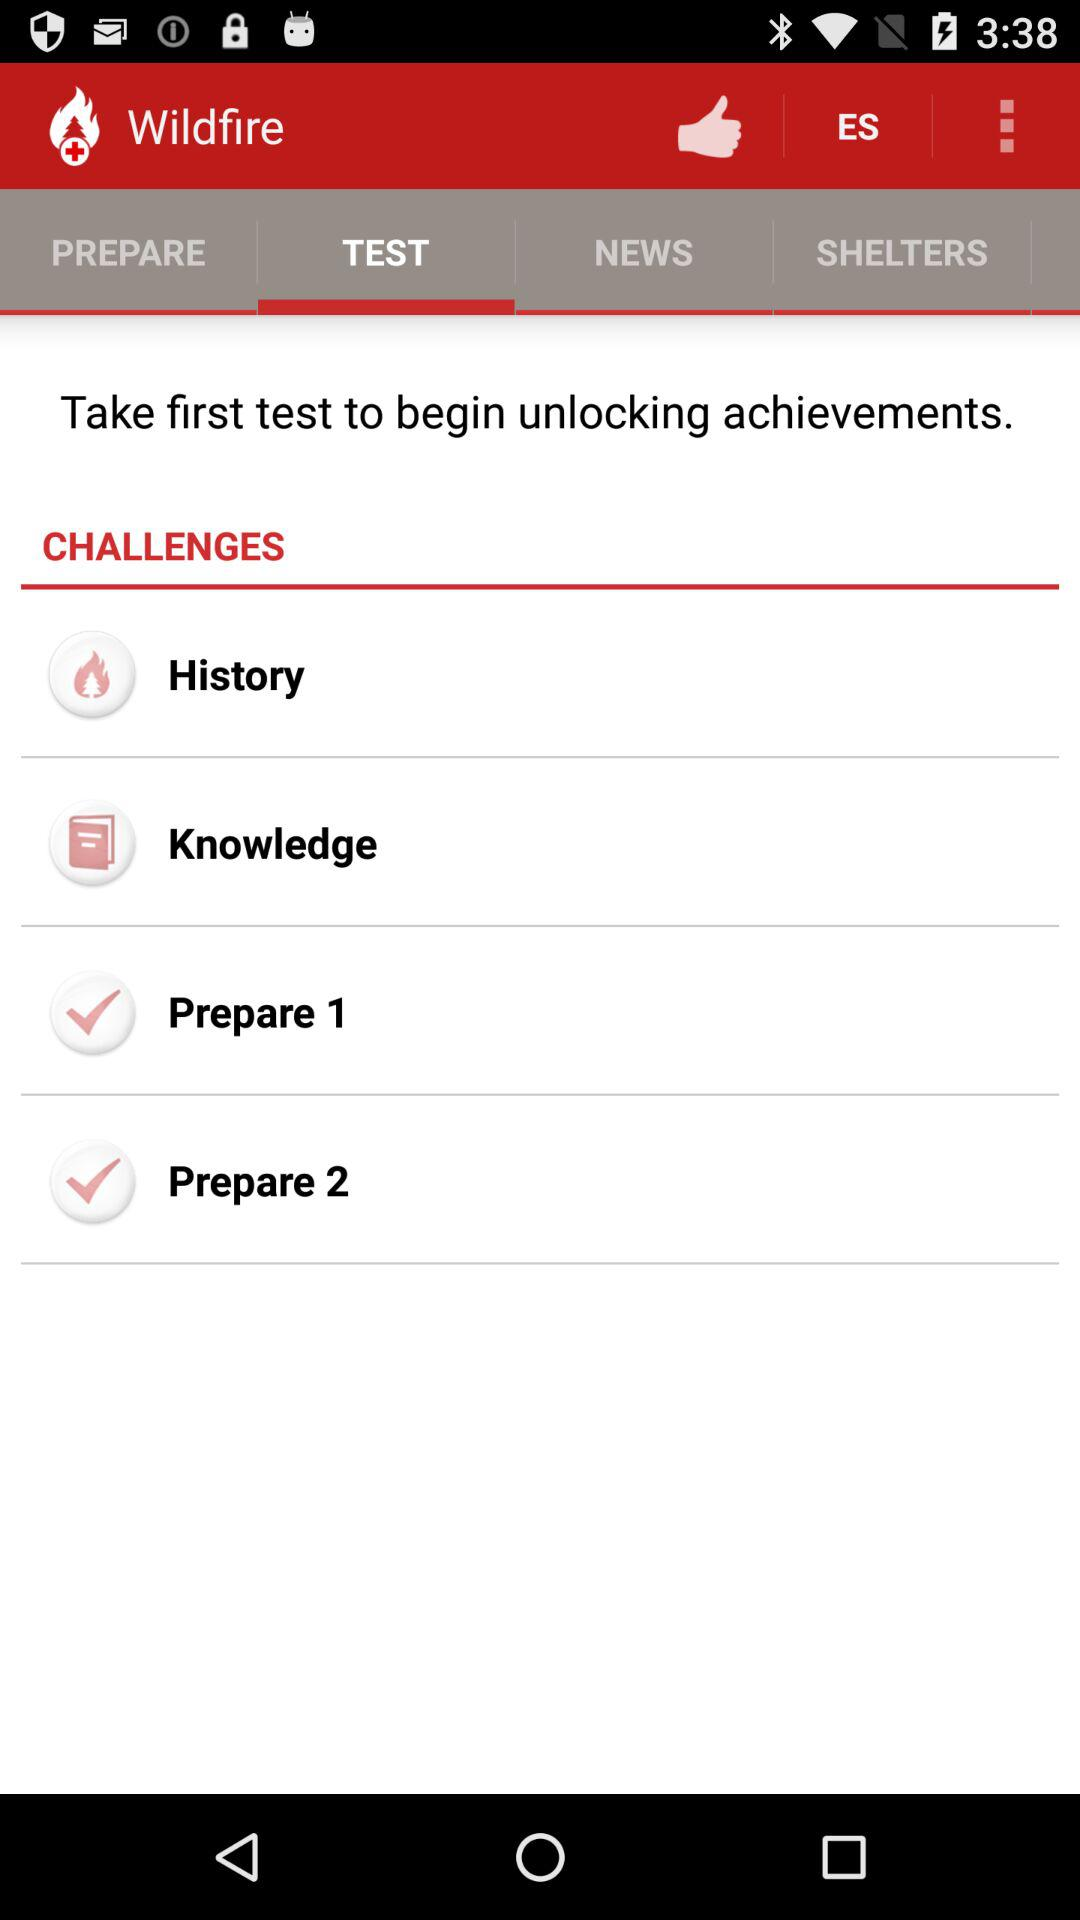Which tab is selected? The selected tab is "TEST". 